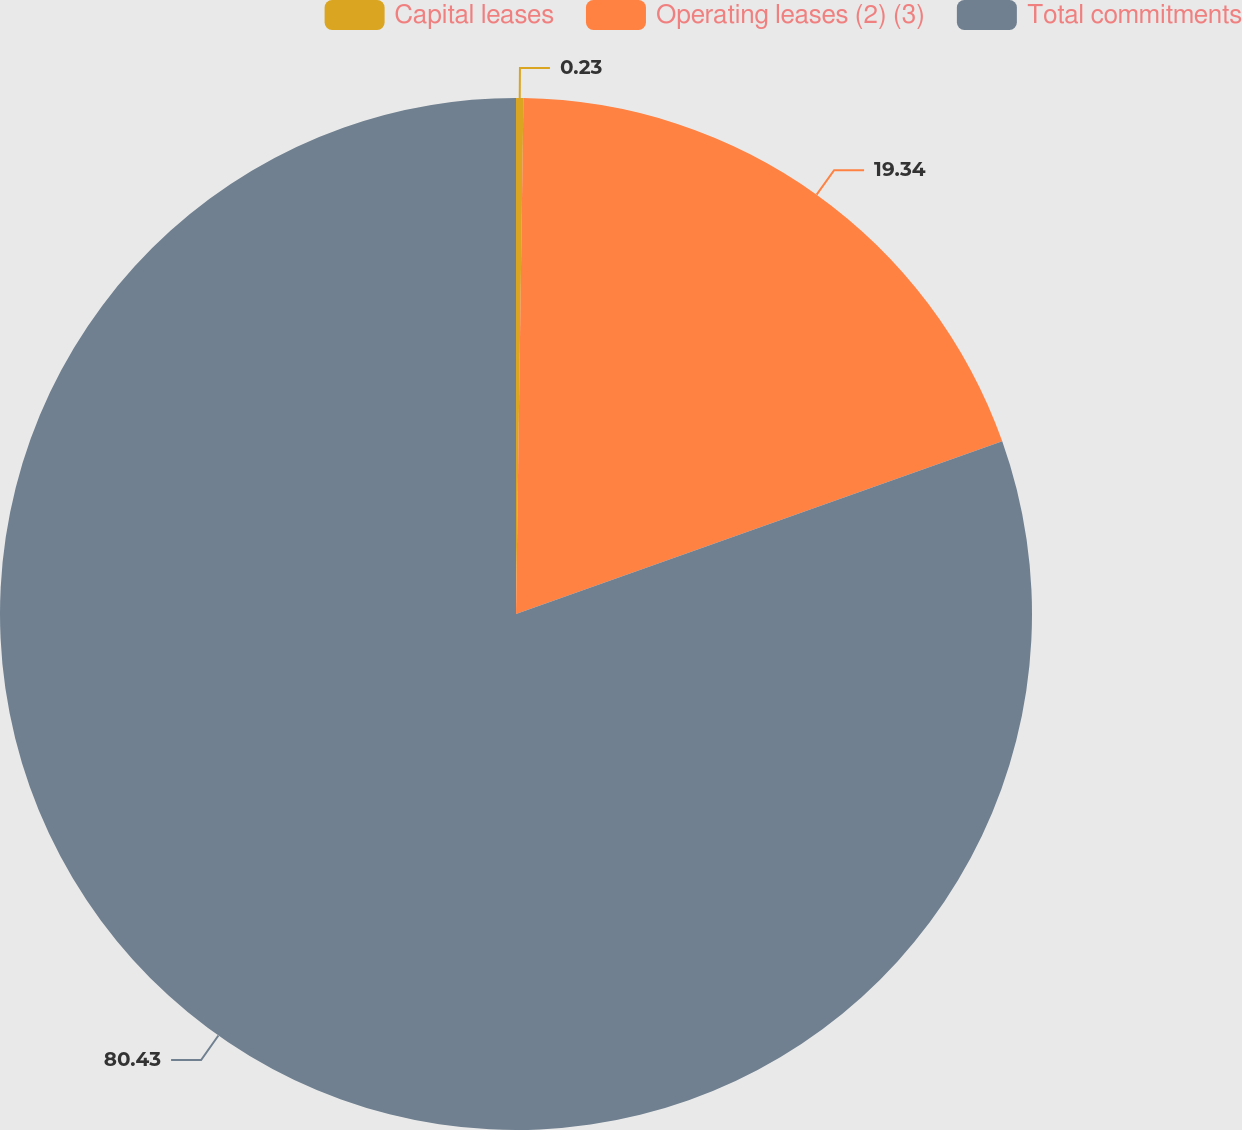Convert chart to OTSL. <chart><loc_0><loc_0><loc_500><loc_500><pie_chart><fcel>Capital leases<fcel>Operating leases (2) (3)<fcel>Total commitments<nl><fcel>0.23%<fcel>19.34%<fcel>80.44%<nl></chart> 